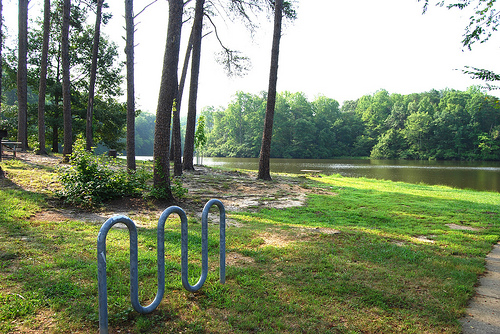<image>
Can you confirm if the rack is next to the water? Yes. The rack is positioned adjacent to the water, located nearby in the same general area. 